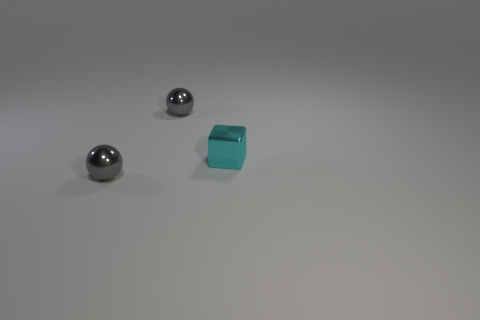What number of other things are the same size as the metal block? There are two spherical objects that appear to be the same size as the metallic block in the image. 